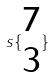<formula> <loc_0><loc_0><loc_500><loc_500>s \{ \begin{matrix} 7 \\ 3 \end{matrix} \}</formula> 